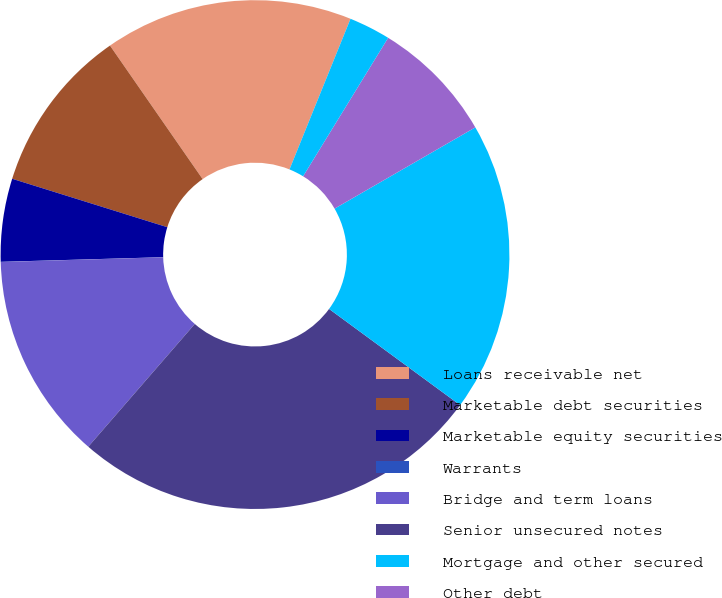Convert chart to OTSL. <chart><loc_0><loc_0><loc_500><loc_500><pie_chart><fcel>Loans receivable net<fcel>Marketable debt securities<fcel>Marketable equity securities<fcel>Warrants<fcel>Bridge and term loans<fcel>Senior unsecured notes<fcel>Mortgage and other secured<fcel>Other debt<fcel>Interest-rate swap liabilities<nl><fcel>15.78%<fcel>10.53%<fcel>5.27%<fcel>0.01%<fcel>13.16%<fcel>26.3%<fcel>18.41%<fcel>7.9%<fcel>2.64%<nl></chart> 